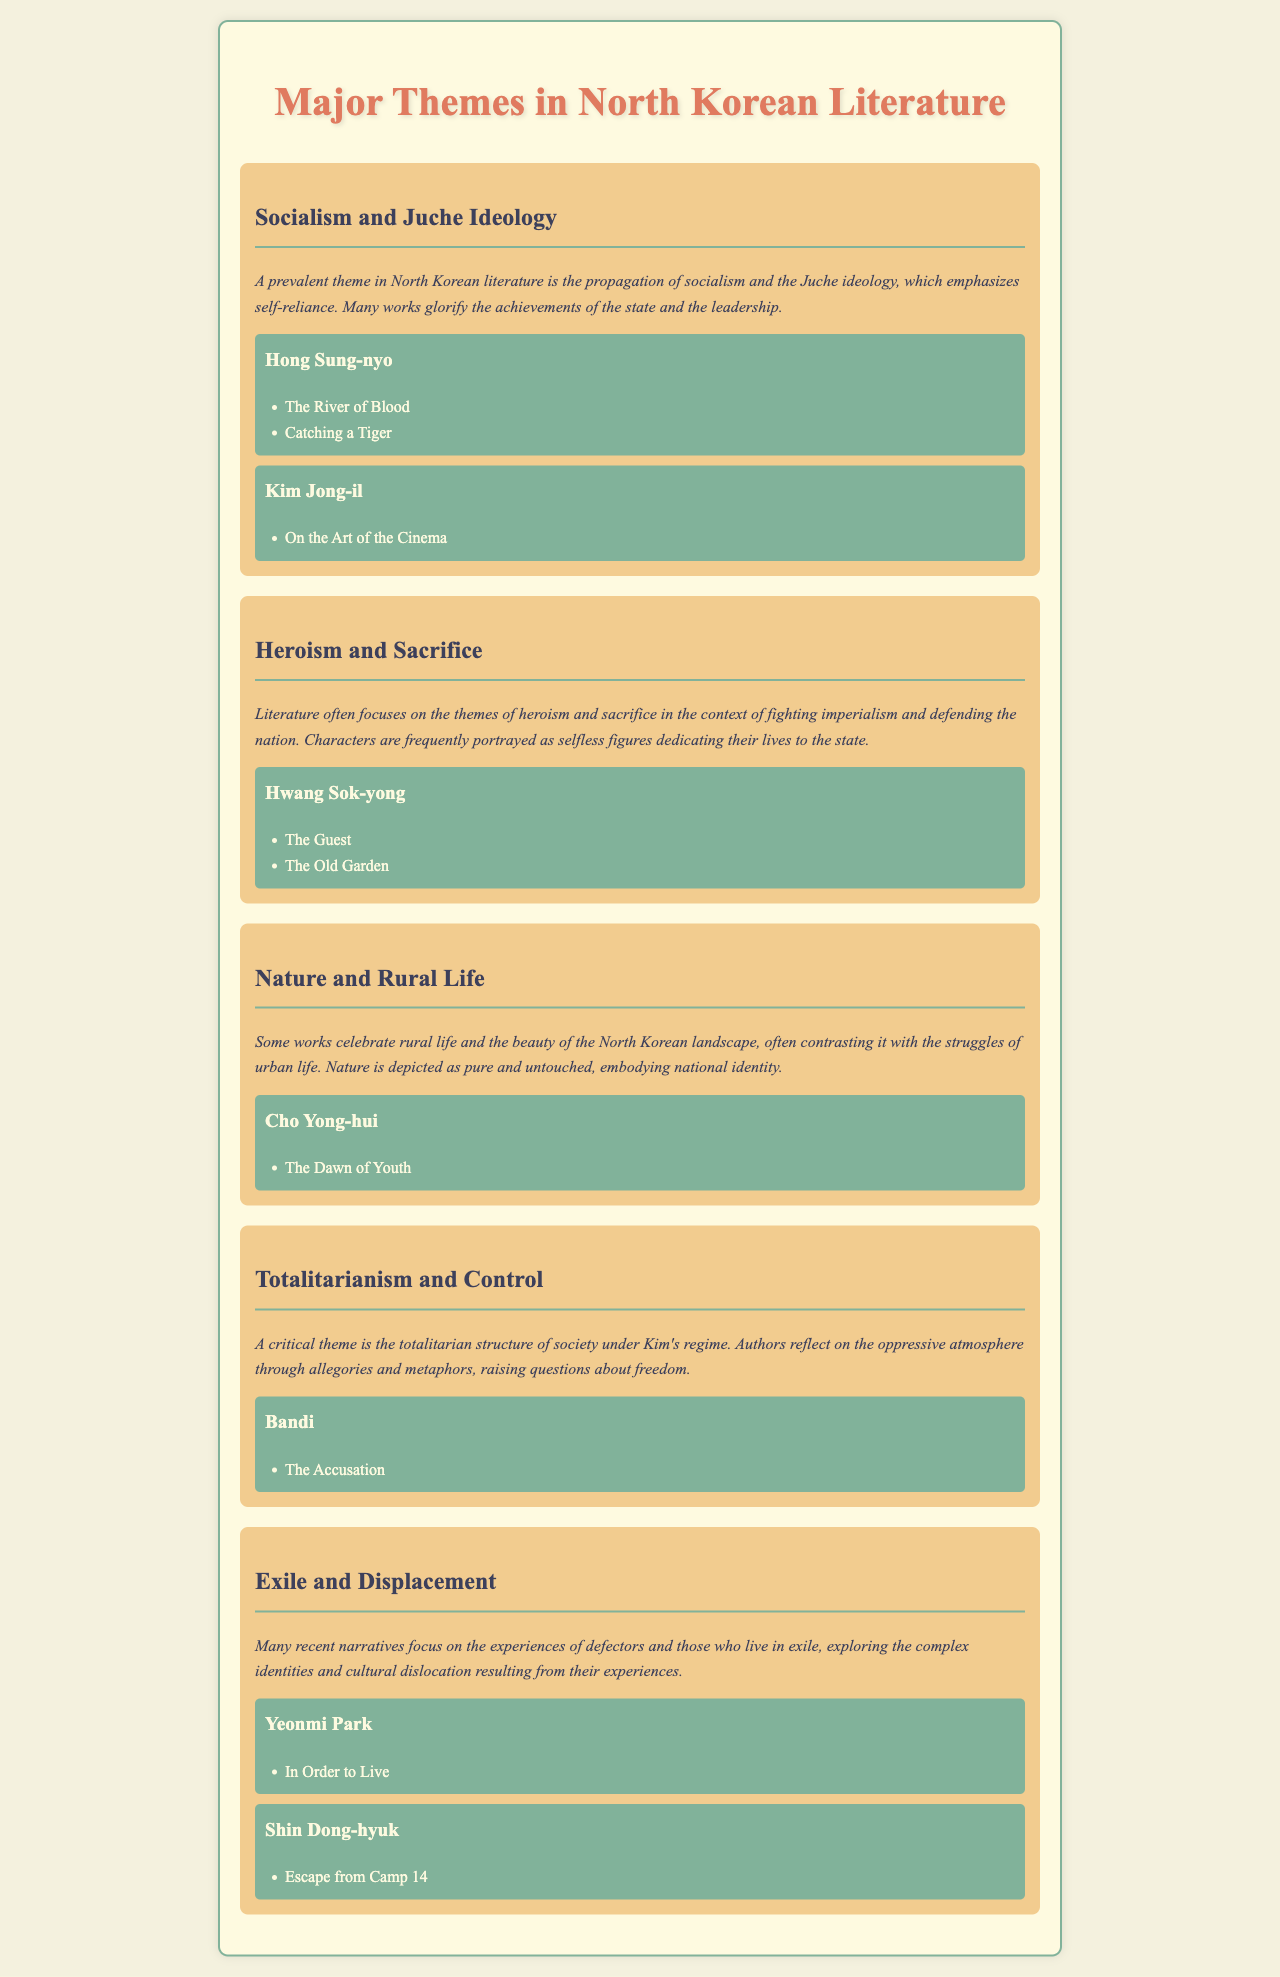What is a prevalent theme in North Korean literature? The document states that socialism and Juche ideology is a prevalent theme, emphasizing self-reliance and the achievements of the state.
Answer: socialism and Juche ideology Who wrote "The Accusation"? The document lists Bandi as the author of "The Accusation" under the theme of totalitarianism and control.
Answer: Bandi Which author is associated with the theme of heroism and sacrifice? The document indicates that Hwang Sok-yong is the author linked to the theme of heroism and sacrifice.
Answer: Hwang Sok-yong What book did Yeonmi Park write? According to the document, Yeonmi Park authored "In Order to Live," which is related to the theme of exile and displacement.
Answer: In Order to Live How many works are listed under the theme of nature and rural life? The document mentions one work under the theme of nature and rural life, which is "The Dawn of Youth."
Answer: one Which theme explores the oppressive atmosphere of North Korean society? The document states that the theme of totalitarianism and control reflects on the oppressive atmosphere under Kim's regime.
Answer: totalitarianism and control 